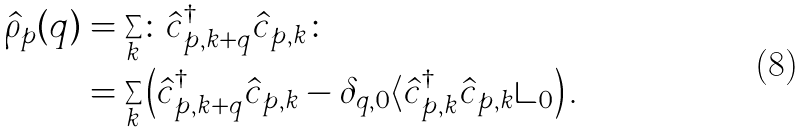<formula> <loc_0><loc_0><loc_500><loc_500>\hat { \rho } _ { p } ( q ) & = \sum _ { k } \colon \hat { c } ^ { \dagger } _ { p , k + q } \hat { c } _ { p , k } \colon \\ & = \sum _ { k } \left ( \hat { c } ^ { \dagger } _ { p , k + q } \hat { c } _ { p , k } - \delta _ { q , 0 } \langle \hat { c } ^ { \dagger } _ { p , k } \hat { c } _ { p , k } \rangle _ { 0 } \right ) .</formula> 